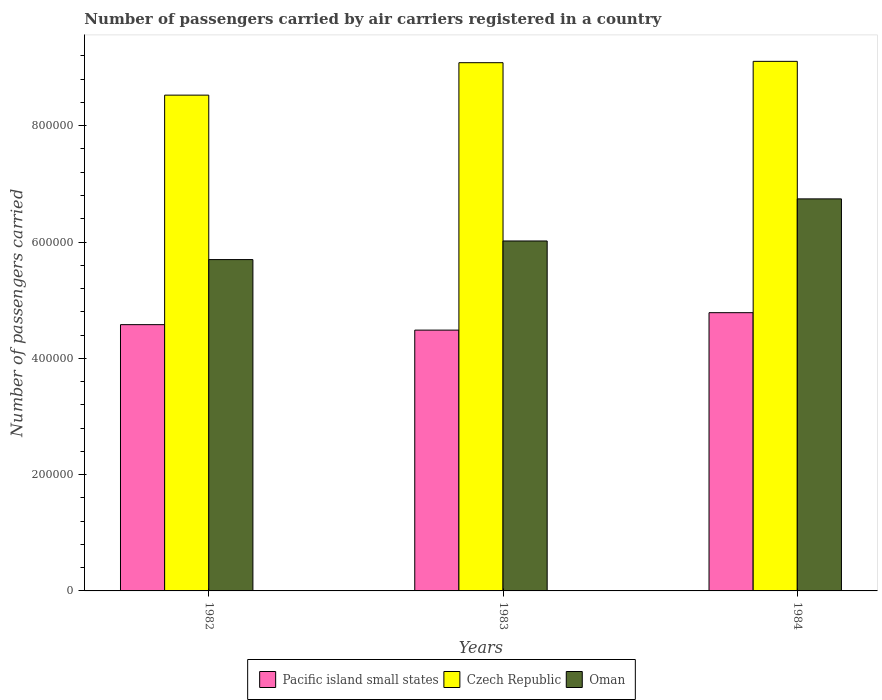How many bars are there on the 2nd tick from the left?
Your answer should be very brief. 3. How many bars are there on the 2nd tick from the right?
Offer a very short reply. 3. What is the label of the 3rd group of bars from the left?
Provide a succinct answer. 1984. In how many cases, is the number of bars for a given year not equal to the number of legend labels?
Provide a short and direct response. 0. What is the number of passengers carried by air carriers in Pacific island small states in 1984?
Offer a very short reply. 4.78e+05. Across all years, what is the maximum number of passengers carried by air carriers in Oman?
Keep it short and to the point. 6.74e+05. Across all years, what is the minimum number of passengers carried by air carriers in Pacific island small states?
Give a very brief answer. 4.48e+05. In which year was the number of passengers carried by air carriers in Oman maximum?
Make the answer very short. 1984. In which year was the number of passengers carried by air carriers in Czech Republic minimum?
Provide a succinct answer. 1982. What is the total number of passengers carried by air carriers in Oman in the graph?
Offer a very short reply. 1.85e+06. What is the difference between the number of passengers carried by air carriers in Czech Republic in 1982 and that in 1983?
Make the answer very short. -5.58e+04. What is the difference between the number of passengers carried by air carriers in Czech Republic in 1982 and the number of passengers carried by air carriers in Oman in 1984?
Offer a terse response. 1.78e+05. What is the average number of passengers carried by air carriers in Czech Republic per year?
Offer a terse response. 8.91e+05. In the year 1984, what is the difference between the number of passengers carried by air carriers in Pacific island small states and number of passengers carried by air carriers in Czech Republic?
Make the answer very short. -4.32e+05. What is the ratio of the number of passengers carried by air carriers in Oman in 1983 to that in 1984?
Ensure brevity in your answer.  0.89. Is the difference between the number of passengers carried by air carriers in Pacific island small states in 1982 and 1983 greater than the difference between the number of passengers carried by air carriers in Czech Republic in 1982 and 1983?
Ensure brevity in your answer.  Yes. What is the difference between the highest and the second highest number of passengers carried by air carriers in Czech Republic?
Provide a succinct answer. 2300. What is the difference between the highest and the lowest number of passengers carried by air carriers in Pacific island small states?
Your answer should be very brief. 3.00e+04. In how many years, is the number of passengers carried by air carriers in Czech Republic greater than the average number of passengers carried by air carriers in Czech Republic taken over all years?
Provide a succinct answer. 2. Is the sum of the number of passengers carried by air carriers in Pacific island small states in 1982 and 1983 greater than the maximum number of passengers carried by air carriers in Oman across all years?
Your answer should be very brief. Yes. What does the 1st bar from the left in 1982 represents?
Provide a short and direct response. Pacific island small states. What does the 3rd bar from the right in 1984 represents?
Make the answer very short. Pacific island small states. How many bars are there?
Offer a very short reply. 9. How many years are there in the graph?
Offer a very short reply. 3. What is the difference between two consecutive major ticks on the Y-axis?
Offer a very short reply. 2.00e+05. How are the legend labels stacked?
Offer a very short reply. Horizontal. What is the title of the graph?
Make the answer very short. Number of passengers carried by air carriers registered in a country. What is the label or title of the X-axis?
Make the answer very short. Years. What is the label or title of the Y-axis?
Your response must be concise. Number of passengers carried. What is the Number of passengers carried in Pacific island small states in 1982?
Offer a terse response. 4.58e+05. What is the Number of passengers carried of Czech Republic in 1982?
Make the answer very short. 8.53e+05. What is the Number of passengers carried in Oman in 1982?
Offer a very short reply. 5.70e+05. What is the Number of passengers carried of Pacific island small states in 1983?
Keep it short and to the point. 4.48e+05. What is the Number of passengers carried of Czech Republic in 1983?
Your answer should be very brief. 9.08e+05. What is the Number of passengers carried of Oman in 1983?
Your answer should be very brief. 6.02e+05. What is the Number of passengers carried in Pacific island small states in 1984?
Give a very brief answer. 4.78e+05. What is the Number of passengers carried of Czech Republic in 1984?
Keep it short and to the point. 9.11e+05. What is the Number of passengers carried in Oman in 1984?
Make the answer very short. 6.74e+05. Across all years, what is the maximum Number of passengers carried of Pacific island small states?
Provide a succinct answer. 4.78e+05. Across all years, what is the maximum Number of passengers carried in Czech Republic?
Make the answer very short. 9.11e+05. Across all years, what is the maximum Number of passengers carried of Oman?
Your answer should be compact. 6.74e+05. Across all years, what is the minimum Number of passengers carried in Pacific island small states?
Offer a very short reply. 4.48e+05. Across all years, what is the minimum Number of passengers carried in Czech Republic?
Keep it short and to the point. 8.53e+05. Across all years, what is the minimum Number of passengers carried of Oman?
Make the answer very short. 5.70e+05. What is the total Number of passengers carried of Pacific island small states in the graph?
Offer a very short reply. 1.38e+06. What is the total Number of passengers carried in Czech Republic in the graph?
Your answer should be very brief. 2.67e+06. What is the total Number of passengers carried in Oman in the graph?
Your response must be concise. 1.85e+06. What is the difference between the Number of passengers carried in Pacific island small states in 1982 and that in 1983?
Make the answer very short. 9400. What is the difference between the Number of passengers carried of Czech Republic in 1982 and that in 1983?
Make the answer very short. -5.58e+04. What is the difference between the Number of passengers carried of Oman in 1982 and that in 1983?
Make the answer very short. -3.20e+04. What is the difference between the Number of passengers carried of Pacific island small states in 1982 and that in 1984?
Give a very brief answer. -2.06e+04. What is the difference between the Number of passengers carried in Czech Republic in 1982 and that in 1984?
Make the answer very short. -5.81e+04. What is the difference between the Number of passengers carried of Oman in 1982 and that in 1984?
Your answer should be compact. -1.04e+05. What is the difference between the Number of passengers carried in Czech Republic in 1983 and that in 1984?
Provide a succinct answer. -2300. What is the difference between the Number of passengers carried of Oman in 1983 and that in 1984?
Offer a terse response. -7.24e+04. What is the difference between the Number of passengers carried of Pacific island small states in 1982 and the Number of passengers carried of Czech Republic in 1983?
Give a very brief answer. -4.50e+05. What is the difference between the Number of passengers carried in Pacific island small states in 1982 and the Number of passengers carried in Oman in 1983?
Provide a short and direct response. -1.44e+05. What is the difference between the Number of passengers carried in Czech Republic in 1982 and the Number of passengers carried in Oman in 1983?
Keep it short and to the point. 2.51e+05. What is the difference between the Number of passengers carried in Pacific island small states in 1982 and the Number of passengers carried in Czech Republic in 1984?
Keep it short and to the point. -4.53e+05. What is the difference between the Number of passengers carried of Pacific island small states in 1982 and the Number of passengers carried of Oman in 1984?
Your answer should be very brief. -2.16e+05. What is the difference between the Number of passengers carried in Czech Republic in 1982 and the Number of passengers carried in Oman in 1984?
Provide a short and direct response. 1.78e+05. What is the difference between the Number of passengers carried of Pacific island small states in 1983 and the Number of passengers carried of Czech Republic in 1984?
Your response must be concise. -4.62e+05. What is the difference between the Number of passengers carried of Pacific island small states in 1983 and the Number of passengers carried of Oman in 1984?
Your answer should be compact. -2.26e+05. What is the difference between the Number of passengers carried of Czech Republic in 1983 and the Number of passengers carried of Oman in 1984?
Provide a succinct answer. 2.34e+05. What is the average Number of passengers carried in Pacific island small states per year?
Offer a terse response. 4.62e+05. What is the average Number of passengers carried of Czech Republic per year?
Provide a short and direct response. 8.91e+05. What is the average Number of passengers carried in Oman per year?
Keep it short and to the point. 6.15e+05. In the year 1982, what is the difference between the Number of passengers carried in Pacific island small states and Number of passengers carried in Czech Republic?
Offer a terse response. -3.95e+05. In the year 1982, what is the difference between the Number of passengers carried in Pacific island small states and Number of passengers carried in Oman?
Your response must be concise. -1.12e+05. In the year 1982, what is the difference between the Number of passengers carried of Czech Republic and Number of passengers carried of Oman?
Give a very brief answer. 2.83e+05. In the year 1983, what is the difference between the Number of passengers carried of Pacific island small states and Number of passengers carried of Czech Republic?
Offer a very short reply. -4.60e+05. In the year 1983, what is the difference between the Number of passengers carried of Pacific island small states and Number of passengers carried of Oman?
Offer a terse response. -1.53e+05. In the year 1983, what is the difference between the Number of passengers carried in Czech Republic and Number of passengers carried in Oman?
Provide a succinct answer. 3.07e+05. In the year 1984, what is the difference between the Number of passengers carried of Pacific island small states and Number of passengers carried of Czech Republic?
Offer a terse response. -4.32e+05. In the year 1984, what is the difference between the Number of passengers carried in Pacific island small states and Number of passengers carried in Oman?
Provide a succinct answer. -1.96e+05. In the year 1984, what is the difference between the Number of passengers carried of Czech Republic and Number of passengers carried of Oman?
Make the answer very short. 2.36e+05. What is the ratio of the Number of passengers carried of Pacific island small states in 1982 to that in 1983?
Your response must be concise. 1.02. What is the ratio of the Number of passengers carried in Czech Republic in 1982 to that in 1983?
Your response must be concise. 0.94. What is the ratio of the Number of passengers carried in Oman in 1982 to that in 1983?
Keep it short and to the point. 0.95. What is the ratio of the Number of passengers carried of Pacific island small states in 1982 to that in 1984?
Offer a terse response. 0.96. What is the ratio of the Number of passengers carried in Czech Republic in 1982 to that in 1984?
Provide a succinct answer. 0.94. What is the ratio of the Number of passengers carried of Oman in 1982 to that in 1984?
Make the answer very short. 0.85. What is the ratio of the Number of passengers carried of Pacific island small states in 1983 to that in 1984?
Offer a terse response. 0.94. What is the ratio of the Number of passengers carried in Oman in 1983 to that in 1984?
Offer a terse response. 0.89. What is the difference between the highest and the second highest Number of passengers carried of Pacific island small states?
Make the answer very short. 2.06e+04. What is the difference between the highest and the second highest Number of passengers carried in Czech Republic?
Keep it short and to the point. 2300. What is the difference between the highest and the second highest Number of passengers carried of Oman?
Your answer should be very brief. 7.24e+04. What is the difference between the highest and the lowest Number of passengers carried in Pacific island small states?
Give a very brief answer. 3.00e+04. What is the difference between the highest and the lowest Number of passengers carried in Czech Republic?
Your answer should be very brief. 5.81e+04. What is the difference between the highest and the lowest Number of passengers carried in Oman?
Offer a terse response. 1.04e+05. 